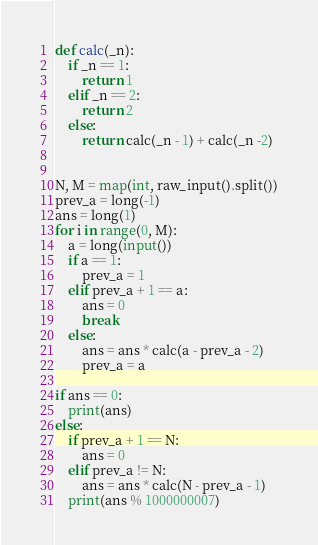<code> <loc_0><loc_0><loc_500><loc_500><_Python_>def calc(_n):
    if _n == 1:
        return 1
    elif _n == 2:
        return 2
    else:
        return calc(_n - 1) + calc(_n -2)


N, M = map(int, raw_input().split())
prev_a = long(-1)
ans = long(1)
for i in range(0, M):
    a = long(input())
    if a == 1:
        prev_a = 1
    elif prev_a + 1 == a:
        ans = 0
        break
    else:
        ans = ans * calc(a - prev_a - 2)
        prev_a = a

if ans == 0:
    print(ans)
else:
    if prev_a + 1 == N:
        ans = 0
    elif prev_a != N:
        ans = ans * calc(N - prev_a - 1)
    print(ans % 1000000007)

</code> 